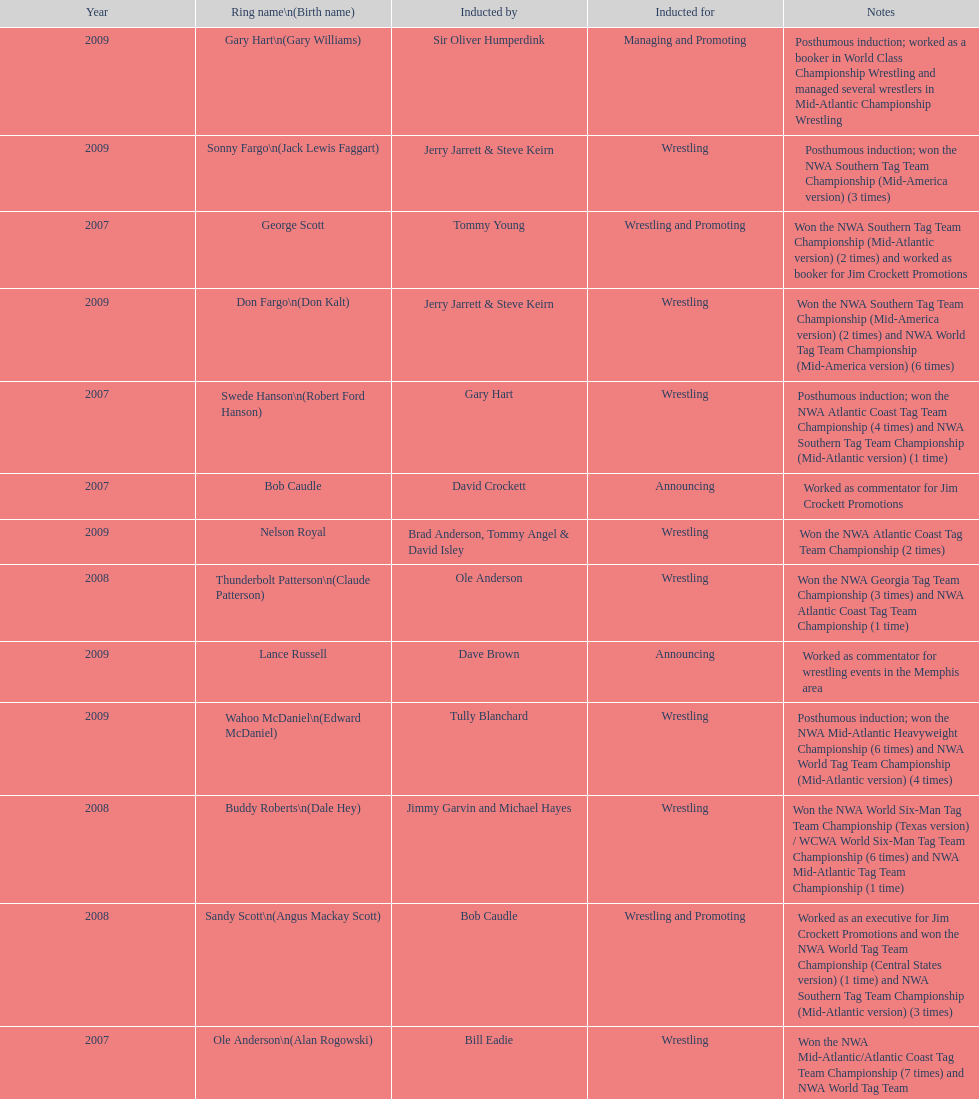Tell me an inductee that was not living at the time. Gene Anderson. 